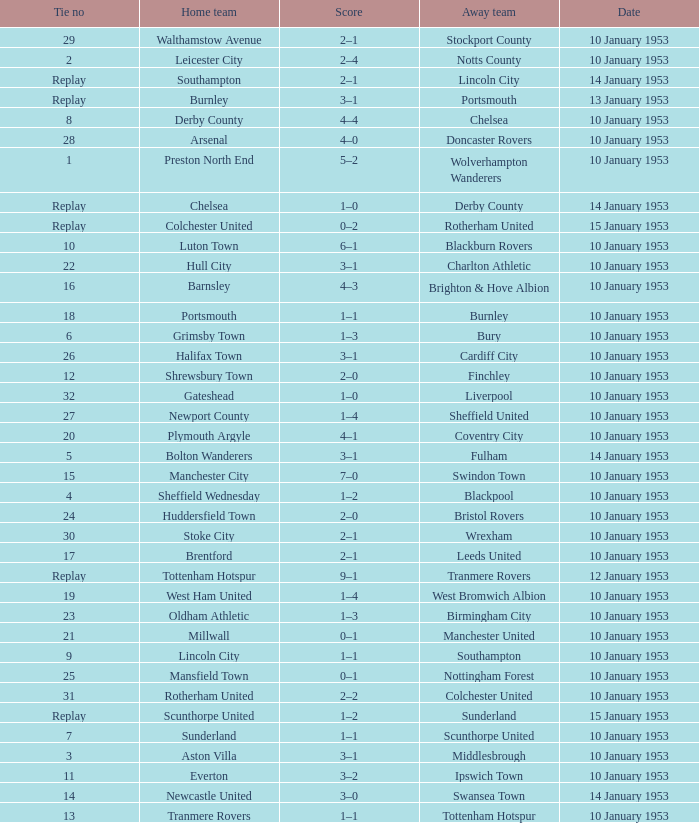What score has charlton athletic as the away team? 3–1. 